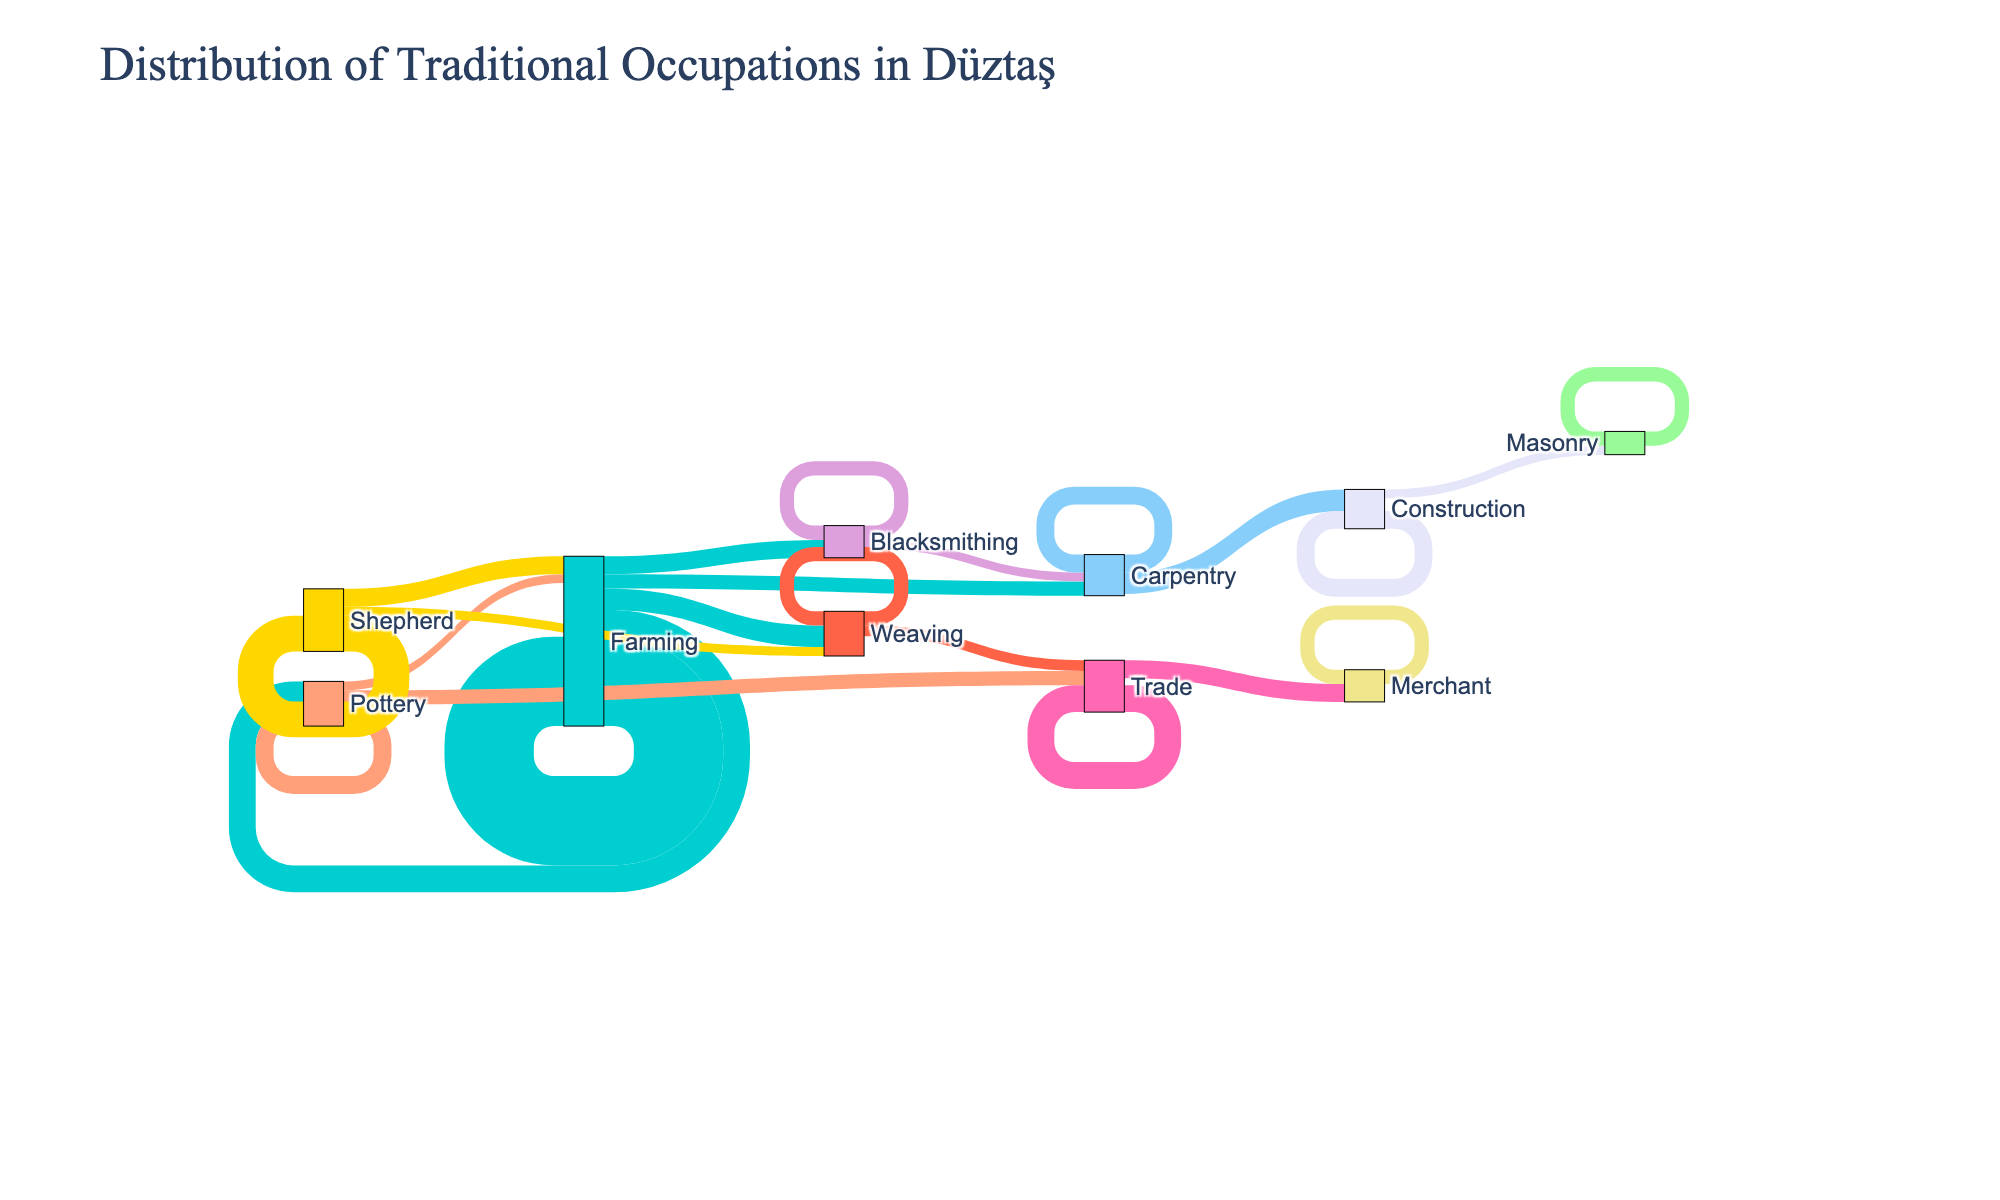what is the most common occupation in the figure? Look at the nodes that have the highest values. Farming appears most frequently with value 50.
Answer: Farming What is the second largest transition from Farming to another occupation? Refer to the transitions from Farming to other occupations. The largest is Farming to Weaving with value 12, and the second largest is from Farming to Pottery with value 15.
Answer: Pottery Which occupation transitioned the least to Trade? Look at the transitions towards Trade. There are transitions from Pottery (8) and Weaving (6). The lowest value is from Weaving.
Answer: Weaving How many transitions originate from Shepherd? Look at the linking lines originating from Shepherd. There are transitions to Shepherd (20), Farming (10), and Weaving (5). Totals 3 transitions.
Answer: 3 Which two occupations are most interconnected with each other? Find pairs of occupations that have transitions both to and from each other. Farming and Pottery have mutual transitions: Farming to Pottery (15) and Pottery to Farming (5).
Answer: Farming, Pottery Which profession did Carpentry transition the most into? Look at transitions originating from Carpentry. The major transition is to Construction with a value of 12.
Answer: Construction Is there any occupation that does not transition to another or back to itself? Every node (occupation) has at least one outgoing or looping transition. Therefore, none is completely isolated.
Answer: No How many professions exist in the diagram? Count unique labels in the nodes. There are 13 distinct professions shown.
Answer: 13 What is the profession that has the least retention within itself? Look at transitions within the same profession. Weaving has a self-transition value of 8.
Answer: Weaving that's also lesser than others like Farming (50), Pottery (10), etc Which professions have no incoming transitions? Examine which nodes do not have any linking lines pointing to them from other nodes. Construction experience no direct transition as all incoming are from Carpentry and Masonry.
Answer: Construction 